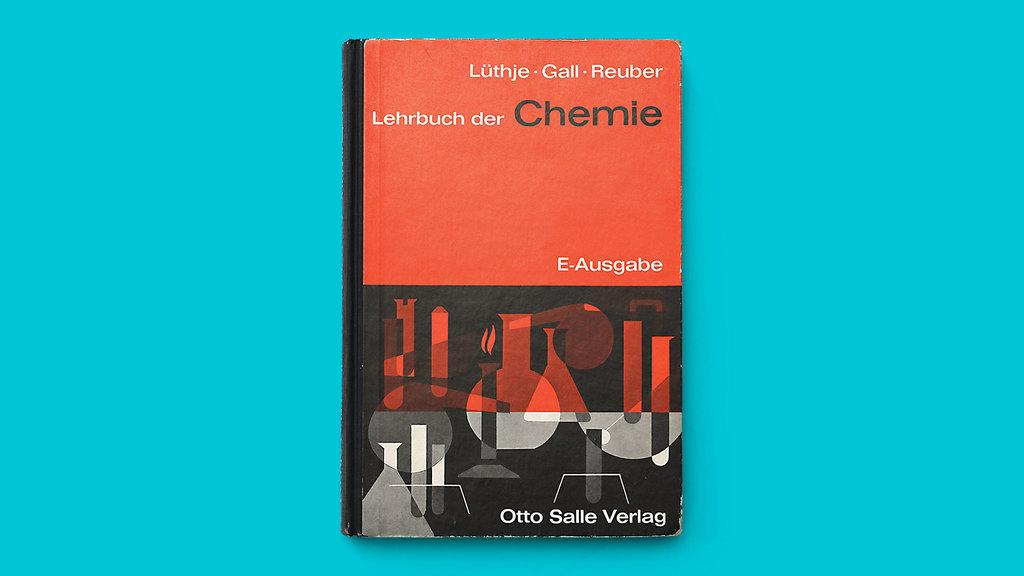<image>
Render a clear and concise summary of the photo. A book titled Chemie is against a blue backdrop. 